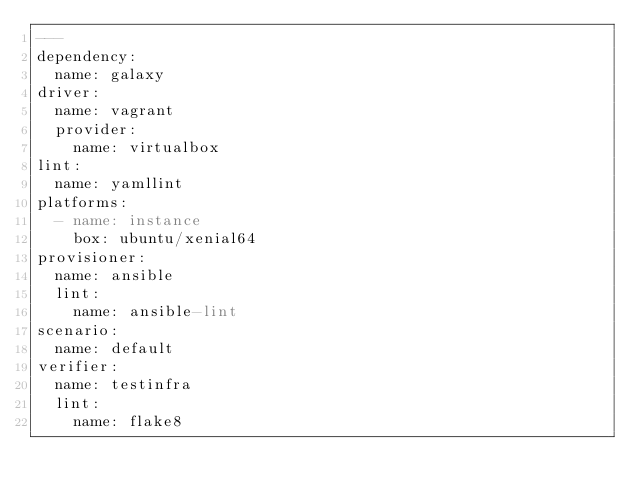Convert code to text. <code><loc_0><loc_0><loc_500><loc_500><_YAML_>---
dependency:
  name: galaxy
driver:
  name: vagrant
  provider:
    name: virtualbox
lint:
  name: yamllint
platforms:
  - name: instance
    box: ubuntu/xenial64
provisioner:
  name: ansible
  lint:
    name: ansible-lint
scenario:
  name: default
verifier:
  name: testinfra
  lint:
    name: flake8

</code> 